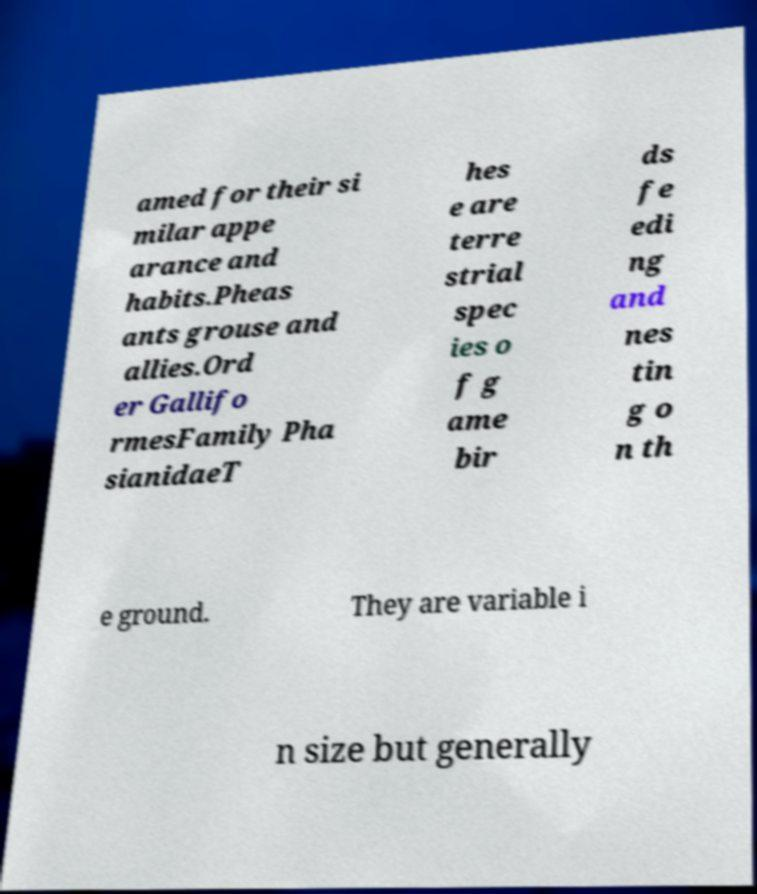I need the written content from this picture converted into text. Can you do that? amed for their si milar appe arance and habits.Pheas ants grouse and allies.Ord er Gallifo rmesFamily Pha sianidaeT hes e are terre strial spec ies o f g ame bir ds fe edi ng and nes tin g o n th e ground. They are variable i n size but generally 